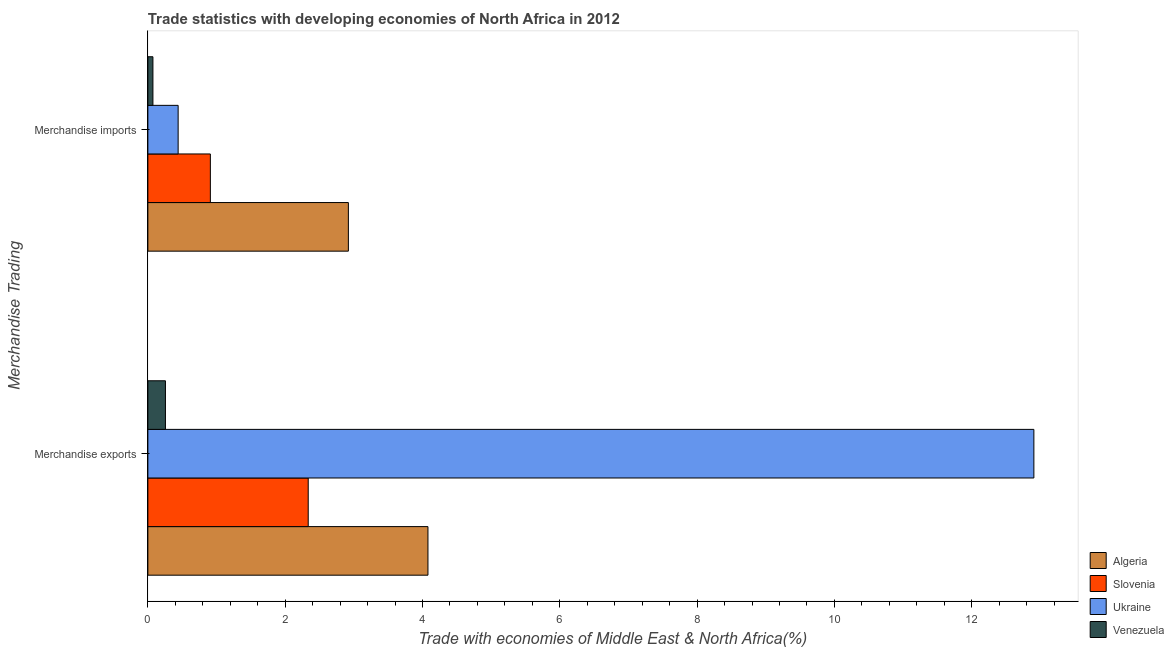How many different coloured bars are there?
Ensure brevity in your answer.  4. How many groups of bars are there?
Keep it short and to the point. 2. Are the number of bars per tick equal to the number of legend labels?
Ensure brevity in your answer.  Yes. Are the number of bars on each tick of the Y-axis equal?
Make the answer very short. Yes. How many bars are there on the 2nd tick from the top?
Your answer should be compact. 4. What is the label of the 1st group of bars from the top?
Keep it short and to the point. Merchandise imports. What is the merchandise imports in Slovenia?
Give a very brief answer. 0.91. Across all countries, what is the maximum merchandise imports?
Offer a very short reply. 2.92. Across all countries, what is the minimum merchandise imports?
Keep it short and to the point. 0.07. In which country was the merchandise imports maximum?
Provide a succinct answer. Algeria. In which country was the merchandise imports minimum?
Give a very brief answer. Venezuela. What is the total merchandise imports in the graph?
Ensure brevity in your answer.  4.35. What is the difference between the merchandise exports in Slovenia and that in Algeria?
Make the answer very short. -1.74. What is the difference between the merchandise exports in Algeria and the merchandise imports in Ukraine?
Your response must be concise. 3.64. What is the average merchandise exports per country?
Provide a succinct answer. 4.89. What is the difference between the merchandise exports and merchandise imports in Algeria?
Make the answer very short. 1.16. In how many countries, is the merchandise imports greater than 8.4 %?
Your response must be concise. 0. What is the ratio of the merchandise imports in Algeria to that in Slovenia?
Your answer should be compact. 3.21. Is the merchandise exports in Algeria less than that in Slovenia?
Keep it short and to the point. No. In how many countries, is the merchandise exports greater than the average merchandise exports taken over all countries?
Your answer should be very brief. 1. What does the 1st bar from the top in Merchandise imports represents?
Offer a very short reply. Venezuela. What does the 4th bar from the bottom in Merchandise exports represents?
Offer a very short reply. Venezuela. Are all the bars in the graph horizontal?
Make the answer very short. Yes. How many countries are there in the graph?
Your answer should be very brief. 4. What is the difference between two consecutive major ticks on the X-axis?
Ensure brevity in your answer.  2. Does the graph contain any zero values?
Provide a short and direct response. No. Does the graph contain grids?
Provide a succinct answer. No. How are the legend labels stacked?
Your answer should be very brief. Vertical. What is the title of the graph?
Provide a short and direct response. Trade statistics with developing economies of North Africa in 2012. What is the label or title of the X-axis?
Ensure brevity in your answer.  Trade with economies of Middle East & North Africa(%). What is the label or title of the Y-axis?
Make the answer very short. Merchandise Trading. What is the Trade with economies of Middle East & North Africa(%) in Algeria in Merchandise exports?
Offer a terse response. 4.08. What is the Trade with economies of Middle East & North Africa(%) of Slovenia in Merchandise exports?
Your answer should be very brief. 2.34. What is the Trade with economies of Middle East & North Africa(%) in Ukraine in Merchandise exports?
Ensure brevity in your answer.  12.91. What is the Trade with economies of Middle East & North Africa(%) in Venezuela in Merchandise exports?
Provide a short and direct response. 0.26. What is the Trade with economies of Middle East & North Africa(%) in Algeria in Merchandise imports?
Keep it short and to the point. 2.92. What is the Trade with economies of Middle East & North Africa(%) in Slovenia in Merchandise imports?
Your answer should be very brief. 0.91. What is the Trade with economies of Middle East & North Africa(%) in Ukraine in Merchandise imports?
Your response must be concise. 0.44. What is the Trade with economies of Middle East & North Africa(%) in Venezuela in Merchandise imports?
Offer a very short reply. 0.07. Across all Merchandise Trading, what is the maximum Trade with economies of Middle East & North Africa(%) of Algeria?
Provide a short and direct response. 4.08. Across all Merchandise Trading, what is the maximum Trade with economies of Middle East & North Africa(%) of Slovenia?
Give a very brief answer. 2.34. Across all Merchandise Trading, what is the maximum Trade with economies of Middle East & North Africa(%) of Ukraine?
Make the answer very short. 12.91. Across all Merchandise Trading, what is the maximum Trade with economies of Middle East & North Africa(%) of Venezuela?
Give a very brief answer. 0.26. Across all Merchandise Trading, what is the minimum Trade with economies of Middle East & North Africa(%) of Algeria?
Offer a very short reply. 2.92. Across all Merchandise Trading, what is the minimum Trade with economies of Middle East & North Africa(%) of Slovenia?
Ensure brevity in your answer.  0.91. Across all Merchandise Trading, what is the minimum Trade with economies of Middle East & North Africa(%) of Ukraine?
Offer a very short reply. 0.44. Across all Merchandise Trading, what is the minimum Trade with economies of Middle East & North Africa(%) in Venezuela?
Your response must be concise. 0.07. What is the total Trade with economies of Middle East & North Africa(%) in Algeria in the graph?
Offer a very short reply. 7. What is the total Trade with economies of Middle East & North Africa(%) of Slovenia in the graph?
Ensure brevity in your answer.  3.25. What is the total Trade with economies of Middle East & North Africa(%) in Ukraine in the graph?
Your answer should be very brief. 13.35. What is the total Trade with economies of Middle East & North Africa(%) of Venezuela in the graph?
Your answer should be compact. 0.33. What is the difference between the Trade with economies of Middle East & North Africa(%) in Algeria in Merchandise exports and that in Merchandise imports?
Ensure brevity in your answer.  1.16. What is the difference between the Trade with economies of Middle East & North Africa(%) of Slovenia in Merchandise exports and that in Merchandise imports?
Make the answer very short. 1.43. What is the difference between the Trade with economies of Middle East & North Africa(%) of Ukraine in Merchandise exports and that in Merchandise imports?
Your answer should be compact. 12.46. What is the difference between the Trade with economies of Middle East & North Africa(%) of Venezuela in Merchandise exports and that in Merchandise imports?
Your response must be concise. 0.18. What is the difference between the Trade with economies of Middle East & North Africa(%) in Algeria in Merchandise exports and the Trade with economies of Middle East & North Africa(%) in Slovenia in Merchandise imports?
Keep it short and to the point. 3.17. What is the difference between the Trade with economies of Middle East & North Africa(%) in Algeria in Merchandise exports and the Trade with economies of Middle East & North Africa(%) in Ukraine in Merchandise imports?
Give a very brief answer. 3.64. What is the difference between the Trade with economies of Middle East & North Africa(%) of Algeria in Merchandise exports and the Trade with economies of Middle East & North Africa(%) of Venezuela in Merchandise imports?
Provide a succinct answer. 4.01. What is the difference between the Trade with economies of Middle East & North Africa(%) of Slovenia in Merchandise exports and the Trade with economies of Middle East & North Africa(%) of Ukraine in Merchandise imports?
Provide a short and direct response. 1.89. What is the difference between the Trade with economies of Middle East & North Africa(%) of Slovenia in Merchandise exports and the Trade with economies of Middle East & North Africa(%) of Venezuela in Merchandise imports?
Your answer should be very brief. 2.26. What is the difference between the Trade with economies of Middle East & North Africa(%) in Ukraine in Merchandise exports and the Trade with economies of Middle East & North Africa(%) in Venezuela in Merchandise imports?
Your answer should be very brief. 12.83. What is the average Trade with economies of Middle East & North Africa(%) of Algeria per Merchandise Trading?
Offer a very short reply. 3.5. What is the average Trade with economies of Middle East & North Africa(%) in Slovenia per Merchandise Trading?
Offer a very short reply. 1.62. What is the average Trade with economies of Middle East & North Africa(%) of Ukraine per Merchandise Trading?
Your answer should be very brief. 6.67. What is the average Trade with economies of Middle East & North Africa(%) of Venezuela per Merchandise Trading?
Provide a succinct answer. 0.16. What is the difference between the Trade with economies of Middle East & North Africa(%) of Algeria and Trade with economies of Middle East & North Africa(%) of Slovenia in Merchandise exports?
Offer a very short reply. 1.74. What is the difference between the Trade with economies of Middle East & North Africa(%) in Algeria and Trade with economies of Middle East & North Africa(%) in Ukraine in Merchandise exports?
Provide a succinct answer. -8.83. What is the difference between the Trade with economies of Middle East & North Africa(%) of Algeria and Trade with economies of Middle East & North Africa(%) of Venezuela in Merchandise exports?
Your answer should be compact. 3.82. What is the difference between the Trade with economies of Middle East & North Africa(%) of Slovenia and Trade with economies of Middle East & North Africa(%) of Ukraine in Merchandise exports?
Provide a succinct answer. -10.57. What is the difference between the Trade with economies of Middle East & North Africa(%) in Slovenia and Trade with economies of Middle East & North Africa(%) in Venezuela in Merchandise exports?
Provide a succinct answer. 2.08. What is the difference between the Trade with economies of Middle East & North Africa(%) of Ukraine and Trade with economies of Middle East & North Africa(%) of Venezuela in Merchandise exports?
Ensure brevity in your answer.  12.65. What is the difference between the Trade with economies of Middle East & North Africa(%) in Algeria and Trade with economies of Middle East & North Africa(%) in Slovenia in Merchandise imports?
Provide a short and direct response. 2.01. What is the difference between the Trade with economies of Middle East & North Africa(%) in Algeria and Trade with economies of Middle East & North Africa(%) in Ukraine in Merchandise imports?
Ensure brevity in your answer.  2.48. What is the difference between the Trade with economies of Middle East & North Africa(%) in Algeria and Trade with economies of Middle East & North Africa(%) in Venezuela in Merchandise imports?
Provide a succinct answer. 2.85. What is the difference between the Trade with economies of Middle East & North Africa(%) in Slovenia and Trade with economies of Middle East & North Africa(%) in Ukraine in Merchandise imports?
Your response must be concise. 0.47. What is the difference between the Trade with economies of Middle East & North Africa(%) in Slovenia and Trade with economies of Middle East & North Africa(%) in Venezuela in Merchandise imports?
Make the answer very short. 0.84. What is the difference between the Trade with economies of Middle East & North Africa(%) in Ukraine and Trade with economies of Middle East & North Africa(%) in Venezuela in Merchandise imports?
Make the answer very short. 0.37. What is the ratio of the Trade with economies of Middle East & North Africa(%) of Algeria in Merchandise exports to that in Merchandise imports?
Ensure brevity in your answer.  1.4. What is the ratio of the Trade with economies of Middle East & North Africa(%) in Slovenia in Merchandise exports to that in Merchandise imports?
Your response must be concise. 2.57. What is the ratio of the Trade with economies of Middle East & North Africa(%) in Ukraine in Merchandise exports to that in Merchandise imports?
Offer a terse response. 29.26. What is the ratio of the Trade with economies of Middle East & North Africa(%) in Venezuela in Merchandise exports to that in Merchandise imports?
Keep it short and to the point. 3.48. What is the difference between the highest and the second highest Trade with economies of Middle East & North Africa(%) of Algeria?
Offer a terse response. 1.16. What is the difference between the highest and the second highest Trade with economies of Middle East & North Africa(%) of Slovenia?
Offer a terse response. 1.43. What is the difference between the highest and the second highest Trade with economies of Middle East & North Africa(%) in Ukraine?
Your response must be concise. 12.46. What is the difference between the highest and the second highest Trade with economies of Middle East & North Africa(%) of Venezuela?
Ensure brevity in your answer.  0.18. What is the difference between the highest and the lowest Trade with economies of Middle East & North Africa(%) in Algeria?
Offer a very short reply. 1.16. What is the difference between the highest and the lowest Trade with economies of Middle East & North Africa(%) of Slovenia?
Offer a very short reply. 1.43. What is the difference between the highest and the lowest Trade with economies of Middle East & North Africa(%) of Ukraine?
Offer a very short reply. 12.46. What is the difference between the highest and the lowest Trade with economies of Middle East & North Africa(%) of Venezuela?
Offer a terse response. 0.18. 